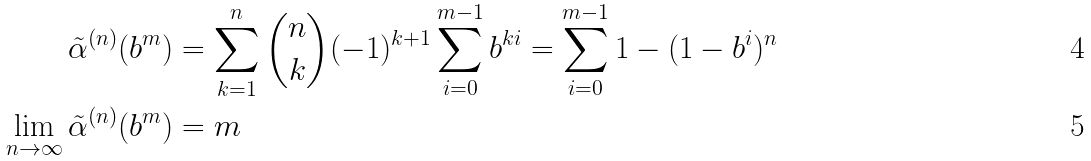Convert formula to latex. <formula><loc_0><loc_0><loc_500><loc_500>\tilde { \alpha } ^ { ( n ) } ( b ^ { m } ) & = \sum _ { k = 1 } ^ { n } \binom { n } { k } ( - 1 ) ^ { k + 1 } \sum _ { i = 0 } ^ { m - 1 } b ^ { k i } = \sum _ { i = 0 } ^ { m - 1 } 1 - ( 1 - b ^ { i } ) ^ { n } \\ \lim _ { n \to \infty } \tilde { \alpha } ^ { ( n ) } ( b ^ { m } ) & = m</formula> 